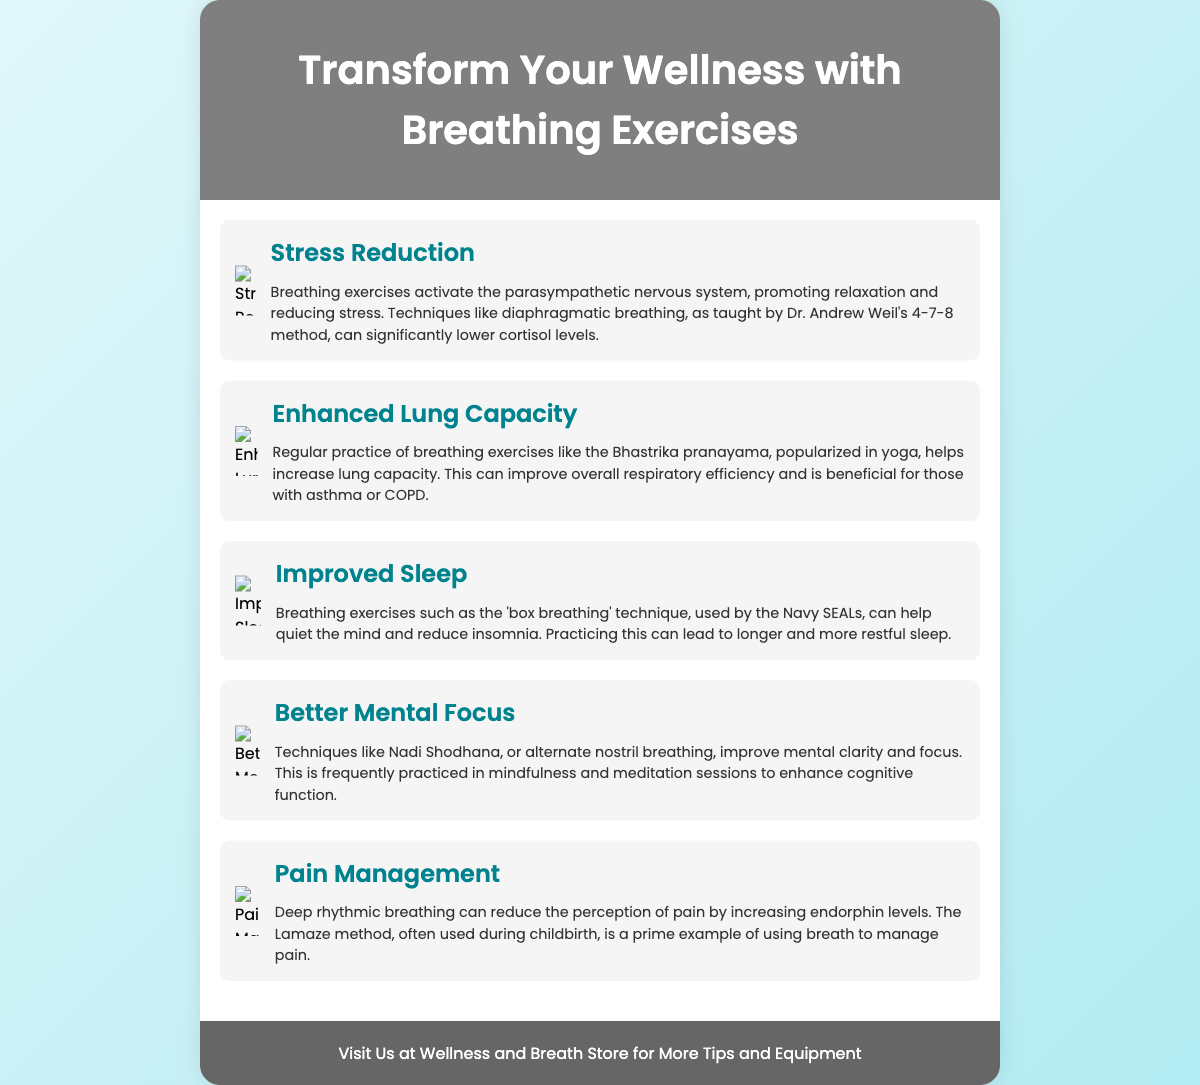What are the benefits of breathing exercises? The poster lists several benefits including stress reduction, enhanced lung capacity, improved sleep, better mental focus, and pain management.
Answer: Stress reduction, enhanced lung capacity, improved sleep, better mental focus, pain management What breathing technique is associated with stress reduction? The poster mentions diaphragmatic breathing techniques, specifically Dr. Andrew Weil's 4-7-8 method for stress reduction.
Answer: 4-7-8 method Which breathing exercise can improve lung capacity? Regular practice of breathing exercises like the Bhastrika pranayama is mentioned as a method to enhance lung capacity.
Answer: Bhastrika pranayama What effect do breathing exercises have on sleep? The poster states that techniques like box breathing can help quiet the mind and reduce insomnia, leading to better sleep.
Answer: Reduce insomnia Which group is mentioned as using box breathing? The poster specifies that box breathing is used by the Navy SEALs as a technique to improve sleep.
Answer: Navy SEALs What color scheme is used in the poster? The background of the poster features a calming gradient of light blue shades.
Answer: Light blue gradient How are the benefits of breathing exercises displayed? The benefits are displayed in a visually appealing manner using infographics and icons along with descriptive text.
Answer: Infographics and icons What is the footer's message? The footer invites viewers to visit the Wellness and Breath Store for more tips and equipment related to breathing exercises.
Answer: Visit Us at Wellness and Breath Store 